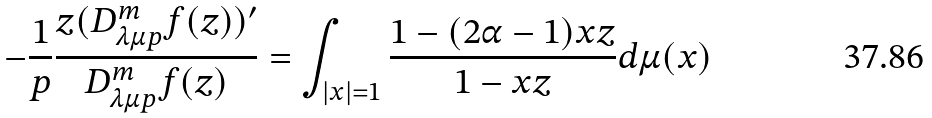<formula> <loc_0><loc_0><loc_500><loc_500>- \frac { 1 } { p } \frac { z ( D _ { \lambda \mu p } ^ { m } f ( z ) ) ^ { \prime } } { D _ { \lambda \mu p } ^ { m } f ( z ) } = \int _ { | x | = 1 } \frac { 1 - ( 2 \alpha - 1 ) x z } { 1 - x z } d \mu ( x )</formula> 